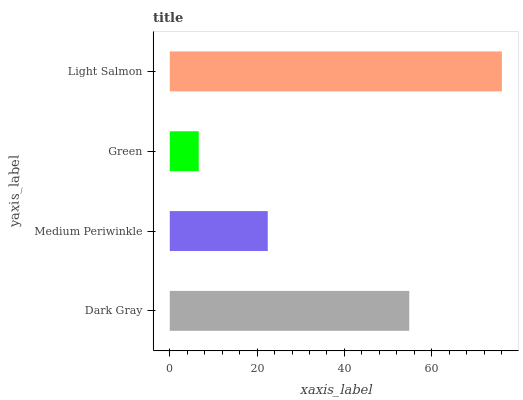Is Green the minimum?
Answer yes or no. Yes. Is Light Salmon the maximum?
Answer yes or no. Yes. Is Medium Periwinkle the minimum?
Answer yes or no. No. Is Medium Periwinkle the maximum?
Answer yes or no. No. Is Dark Gray greater than Medium Periwinkle?
Answer yes or no. Yes. Is Medium Periwinkle less than Dark Gray?
Answer yes or no. Yes. Is Medium Periwinkle greater than Dark Gray?
Answer yes or no. No. Is Dark Gray less than Medium Periwinkle?
Answer yes or no. No. Is Dark Gray the high median?
Answer yes or no. Yes. Is Medium Periwinkle the low median?
Answer yes or no. Yes. Is Green the high median?
Answer yes or no. No. Is Dark Gray the low median?
Answer yes or no. No. 